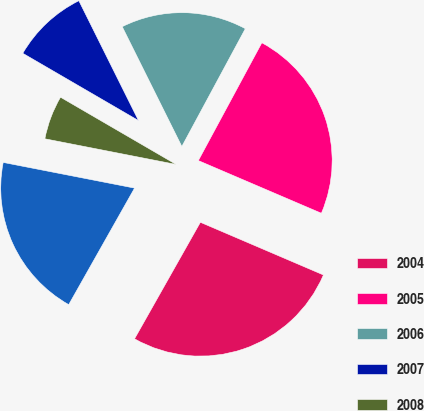<chart> <loc_0><loc_0><loc_500><loc_500><pie_chart><fcel>2004<fcel>2005<fcel>2006<fcel>2007<fcel>2008<fcel>Thereafter<nl><fcel>26.75%<fcel>23.57%<fcel>15.22%<fcel>9.27%<fcel>5.31%<fcel>19.89%<nl></chart> 